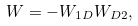Convert formula to latex. <formula><loc_0><loc_0><loc_500><loc_500>W = - W _ { 1 D } W _ { D 2 } ,</formula> 